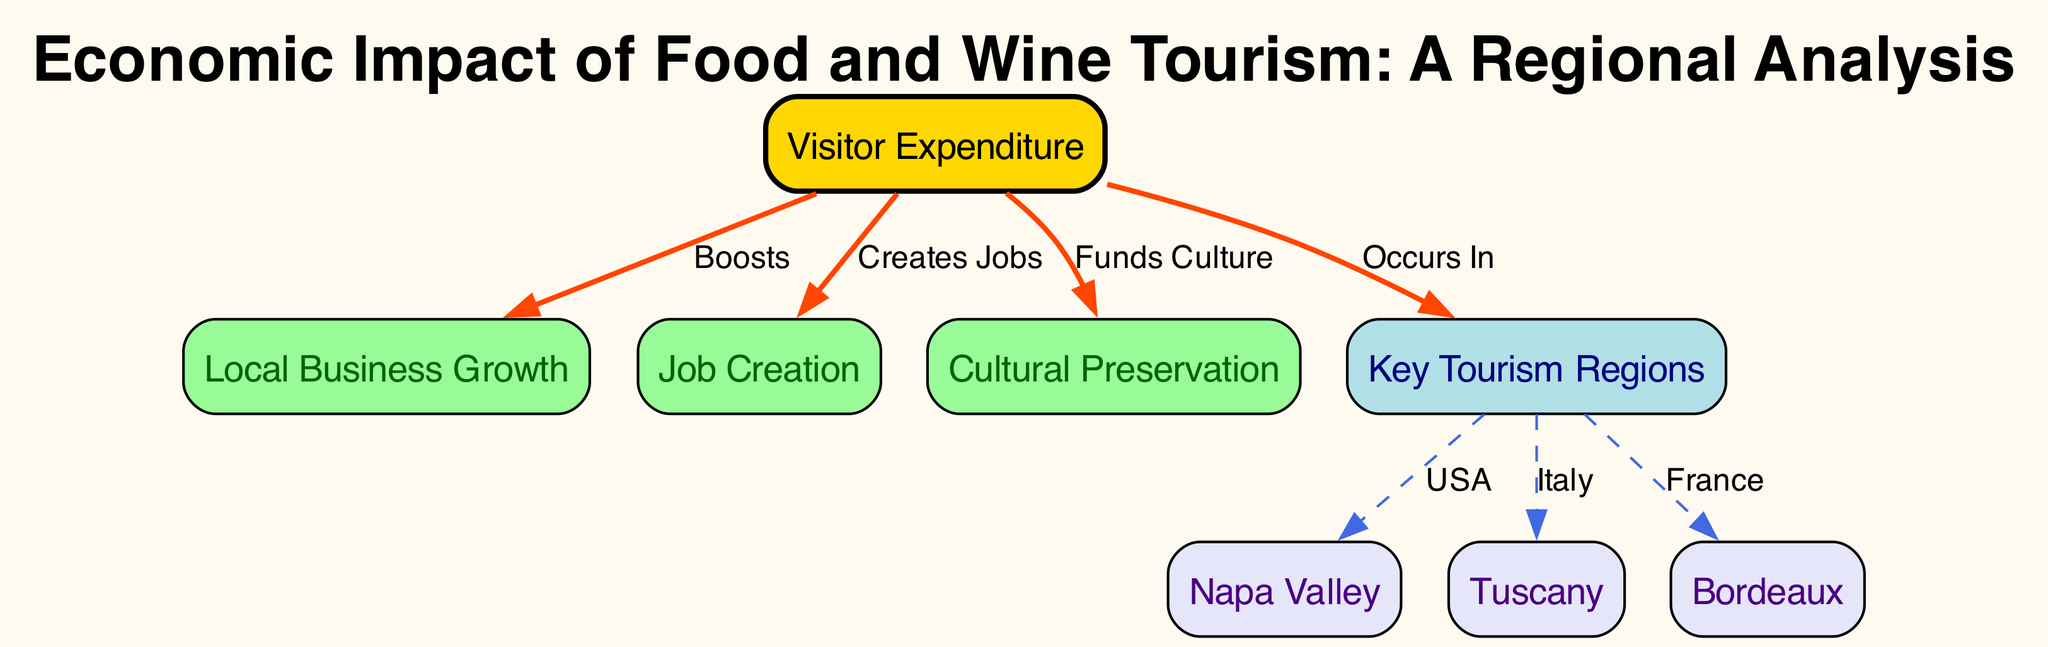What is one of the main benefits of visitor expenditure in the diagram? The diagram shows that visitor expenditure creates jobs, boosts local business growth, and funds cultural preservation. Among these, "creates jobs" is indicated as one of the primary benefits, directly linked from the visitor expenditure node.
Answer: Creates jobs How many key tourism regions are featured in the diagram? The diagram displays three key tourism regions: Napa Valley, Tuscany, and Bordeaux. By counting the specific nodes connected to the 'key regions' node, we confirm there are three distinct regions listed.
Answer: Three What relationship exists between visitor expenditure and local business growth? The diagram indicates that visitor expenditure "boosts" local business growth, forming a direct connection between these two nodes. This is conveyed through an edge that represents the positive impact of visitor expenditure on local businesses.
Answer: Boosts Which region is associated with France in the diagram? According to the connections in the diagram, Bordeaux is indicated as the region that represents France. This association is marked by an edge connecting the 'key regions' node to the Bordeaux node, labeled accordingly.
Answer: Bordeaux What is the function of cultural preservation in the context of visitor expenditure? The diagram highlights that visitor expenditure "funds culture," demonstrating the financial impact that tourism has on maintaining and preserving cultural elements within the region. The relationship is depicted with a directed edge from the visitor expenditure node to the cultural preservation node.
Answer: Funds culture What connects the visitor expenditure node to the key regions node? The diagram shows that visitor expenditure "occurs in" key regions, establishing a foundational relationship indicating that tourism activity and spending take place specifically in those identified areas. This connection highlights the geographic aspect of tourism impact.
Answer: Occurs In How many edges connect the visitor expenditure node to other nodes? The visitor expenditure node connects via three edges: to local business growth, job creation, and cultural preservation. Each of these edges reflects the different impacts of visitor spending, clearly illustrated in the diagram's connections.
Answer: Three What color represents the Napa Valley node in the diagram? The Napa Valley node is marked with a light purple color ('#E6E6FA'), distinct from other nodes. This specific color coding helps differentiate it as one of the key tourism regions within the infographic.
Answer: Light purple What directly links the key regions to the specific countries? The key regions connect to their respective countries through dashed edges labeled as “USA” for Napa Valley, “Italy” for Tuscany, and “France” for Bordeaux, showcasing the international aspect of food and wine tourism.
Answer: Dashed edges 